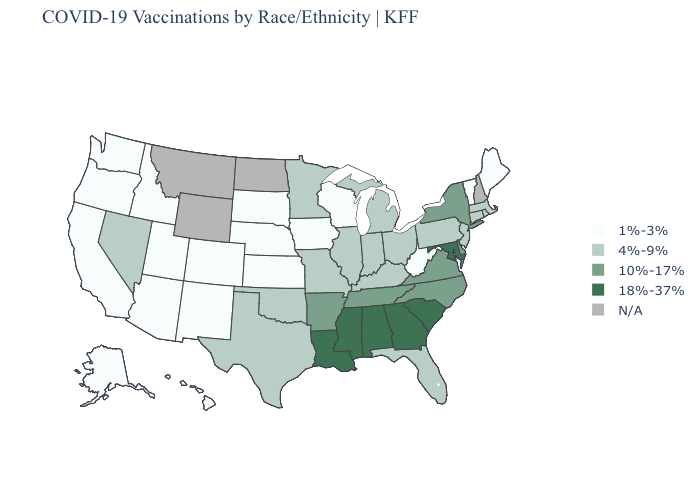Which states have the lowest value in the USA?
Short answer required. Alaska, Arizona, California, Colorado, Hawaii, Idaho, Iowa, Kansas, Maine, Nebraska, New Mexico, Oregon, South Dakota, Utah, Vermont, Washington, West Virginia, Wisconsin. What is the highest value in states that border Ohio?
Short answer required. 4%-9%. Does West Virginia have the lowest value in the South?
Write a very short answer. Yes. What is the lowest value in the USA?
Keep it brief. 1%-3%. What is the value of Alabama?
Keep it brief. 18%-37%. What is the lowest value in states that border Oklahoma?
Quick response, please. 1%-3%. What is the highest value in the West ?
Write a very short answer. 4%-9%. Among the states that border Oregon , which have the highest value?
Concise answer only. Nevada. What is the highest value in states that border Oklahoma?
Keep it brief. 10%-17%. Name the states that have a value in the range 18%-37%?
Short answer required. Alabama, Georgia, Louisiana, Maryland, Mississippi, South Carolina. Which states have the lowest value in the USA?
Short answer required. Alaska, Arizona, California, Colorado, Hawaii, Idaho, Iowa, Kansas, Maine, Nebraska, New Mexico, Oregon, South Dakota, Utah, Vermont, Washington, West Virginia, Wisconsin. Among the states that border North Carolina , does South Carolina have the lowest value?
Concise answer only. No. Which states hav the highest value in the South?
Be succinct. Alabama, Georgia, Louisiana, Maryland, Mississippi, South Carolina. 